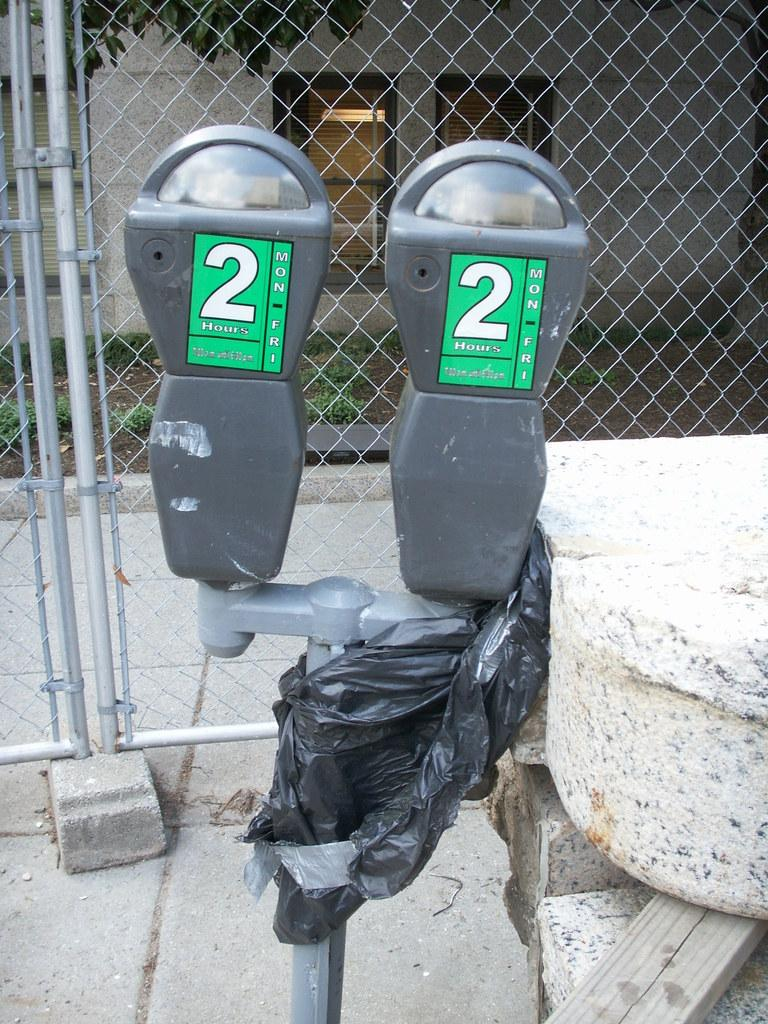<image>
Give a short and clear explanation of the subsequent image. 2 parking meters with the number 2 with green background. 